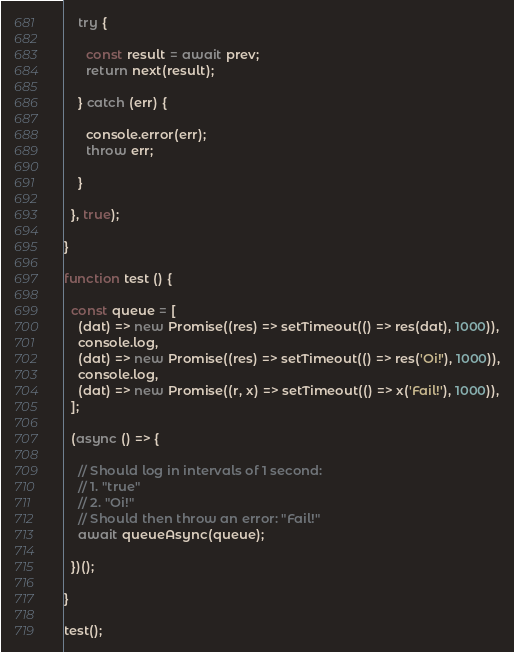Convert code to text. <code><loc_0><loc_0><loc_500><loc_500><_JavaScript_>
    try {

      const result = await prev;
      return next(result);

    } catch (err) {
    
      console.error(err);
      throw err;
    
    }
  
  }, true);

}

function test () {

  const queue = [
    (dat) => new Promise((res) => setTimeout(() => res(dat), 1000)),
    console.log,
    (dat) => new Promise((res) => setTimeout(() => res('Oi!'), 1000)),
    console.log,
    (dat) => new Promise((r, x) => setTimeout(() => x('Fail!'), 1000)),
  ];

  (async () => {

    // Should log in intervals of 1 second:
    // 1. "true"
    // 2. "Oi!"
    // Should then throw an error: "Fail!"
    await queueAsync(queue);

  })();

}

test();
</code> 